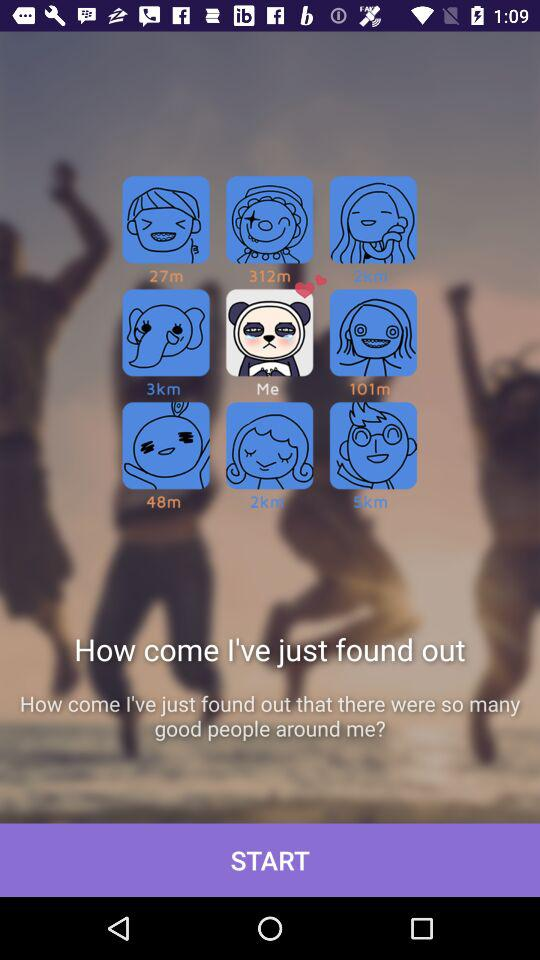How many people have less than 100m distance?
Answer the question using a single word or phrase. 2 